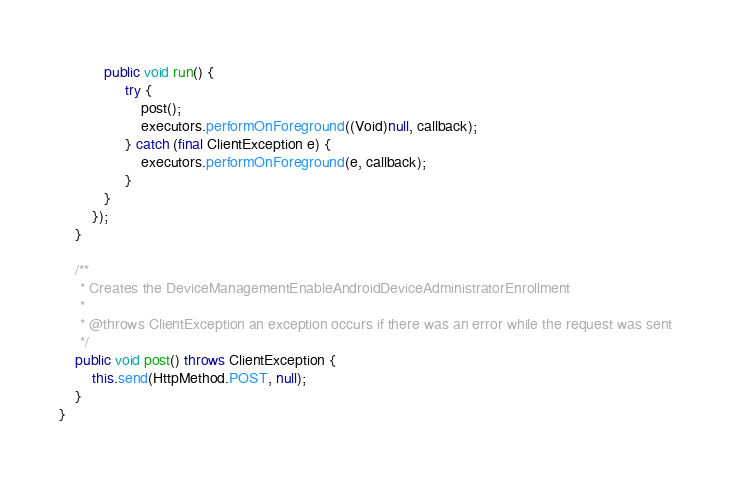Convert code to text. <code><loc_0><loc_0><loc_500><loc_500><_Java_>           public void run() {
                try {
                    post();
                    executors.performOnForeground((Void)null, callback);
                } catch (final ClientException e) {
                    executors.performOnForeground(e, callback);
                }
           }
        });
    }

    /**
     * Creates the DeviceManagementEnableAndroidDeviceAdministratorEnrollment
     *
     * @throws ClientException an exception occurs if there was an error while the request was sent
     */
    public void post() throws ClientException {
        this.send(HttpMethod.POST, null);
    }
}
</code> 